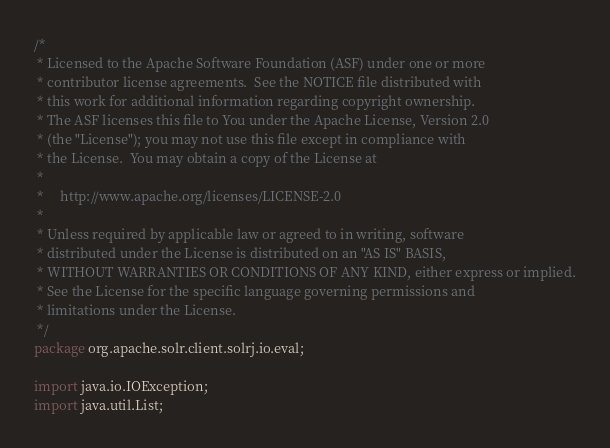<code> <loc_0><loc_0><loc_500><loc_500><_Java_>/*
 * Licensed to the Apache Software Foundation (ASF) under one or more
 * contributor license agreements.  See the NOTICE file distributed with
 * this work for additional information regarding copyright ownership.
 * The ASF licenses this file to You under the Apache License, Version 2.0
 * (the "License"); you may not use this file except in compliance with
 * the License.  You may obtain a copy of the License at
 *
 *     http://www.apache.org/licenses/LICENSE-2.0
 *
 * Unless required by applicable law or agreed to in writing, software
 * distributed under the License is distributed on an "AS IS" BASIS,
 * WITHOUT WARRANTIES OR CONDITIONS OF ANY KIND, either express or implied.
 * See the License for the specific language governing permissions and
 * limitations under the License.
 */
package org.apache.solr.client.solrj.io.eval;

import java.io.IOException;
import java.util.List;</code> 